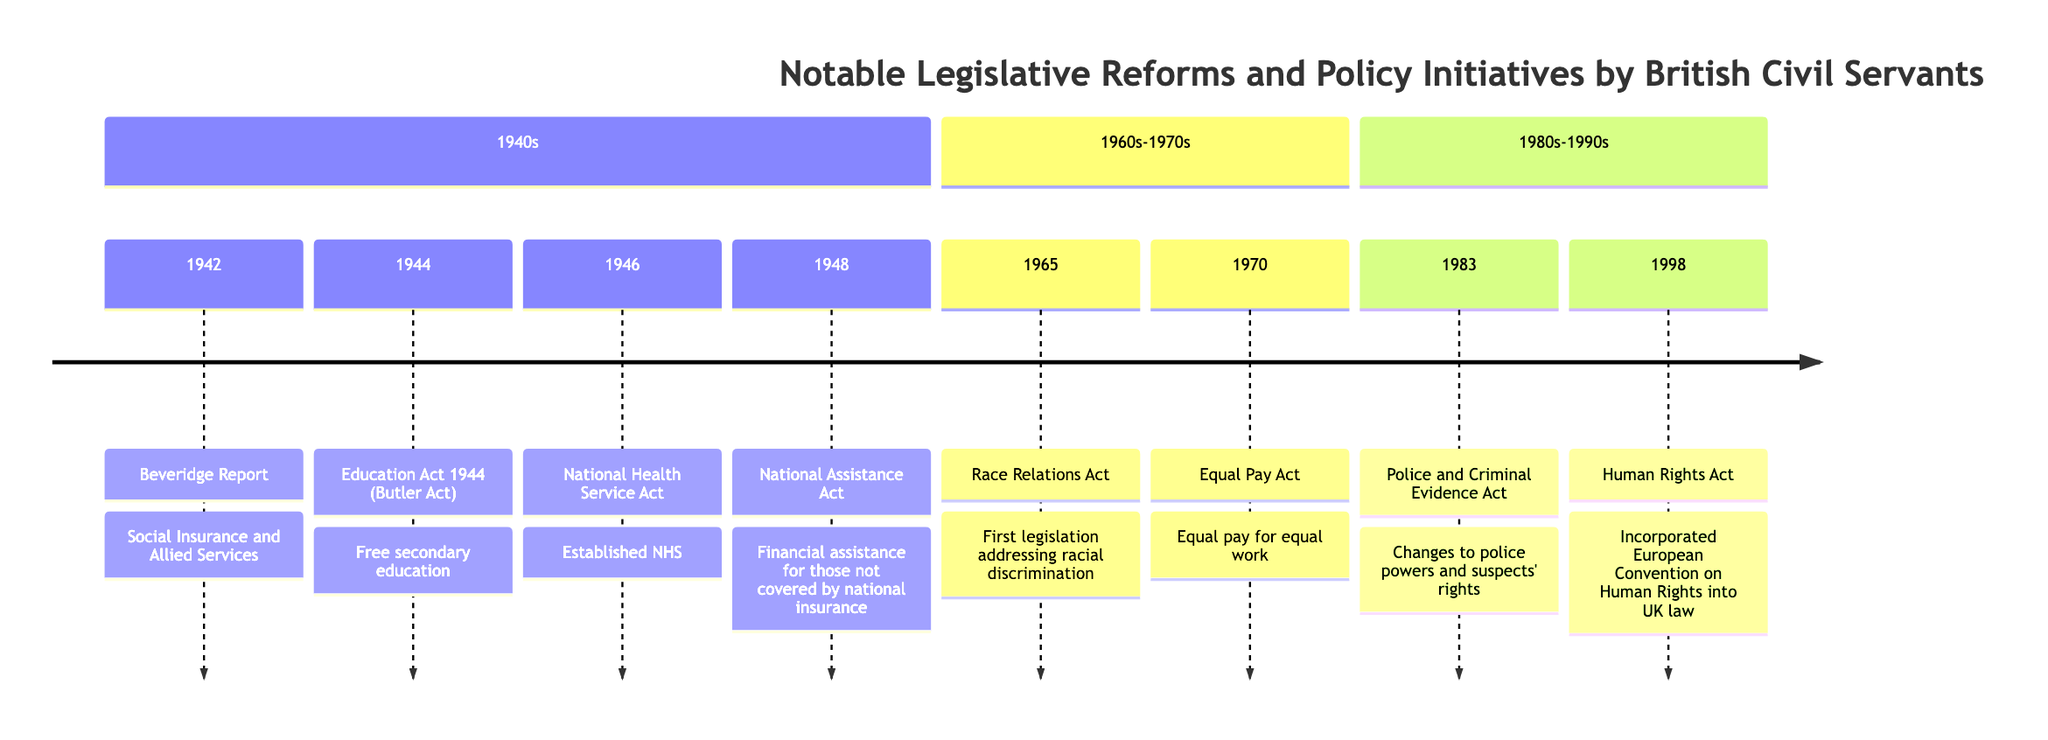What year was the Beveridge Report published? The timeline indicates the year 1942 next to the Beveridge Report. Therefore, the answer is directly found by reading the timeline element related to this report.
Answer: 1942 Which act established the National Health Service? The timeline states that in 1946, the National Health Service Act was implemented, establishing the NHS. This is clearly detailed in the element for 1946.
Answer: National Health Service Act 1946 How many legislative reforms are listed in the 1940s section? In the 1940s section, four reforms are listed: Beveridge Report (1942), Education Act 1944, National Health Service Act 1946, and National Assistance Act 1948. By counting these elements, we find the total.
Answer: 4 What significant change did the Equal Pay Act 1970 address? The timeline details that the Equal Pay Act required equal pay for equal work. This is specifically stated as a key element of this act.
Answer: Equal pay for equal work Which act followed the Race Relations Act in the timeline? The timeline shows that the Race Relations Act occurred in 1965, followed by the Equal Pay Act in 1970. This is determined by checking the years on the timeline in sequence.
Answer: Equal Pay Act 1970 What was the main purpose of the National Assistance Act 1948? According to the timeline, the purpose of this act was to provide financial assistance to those not covered by national insurance, which is explicitly mentioned in the description of the act on the timeline.
Answer: Financial assistance for those not covered by national insurance In which decade was the Human Rights Act enacted? The Human Rights Act is listed under the section covering the 1980s-1990s, indicating that it was enacted in the decade of the 1990s. This is directly observed from the timeline division.
Answer: 1990s How many acts addressing racial discrimination are mentioned? The timeline mentions a single act specifically addressing racial discrimination, which is the Race Relations Act of 1965. This can be confirmed by looking at the elements and counting those related to this theme.
Answer: 1 Which reform was influenced by senior civil servants regarding human rights? The timeline states that the Human Rights Act of 1998 was heavily influenced by senior civil servants in its drafting process. This can be found in the description for the 1998 reform.
Answer: Human Rights Act 1998 